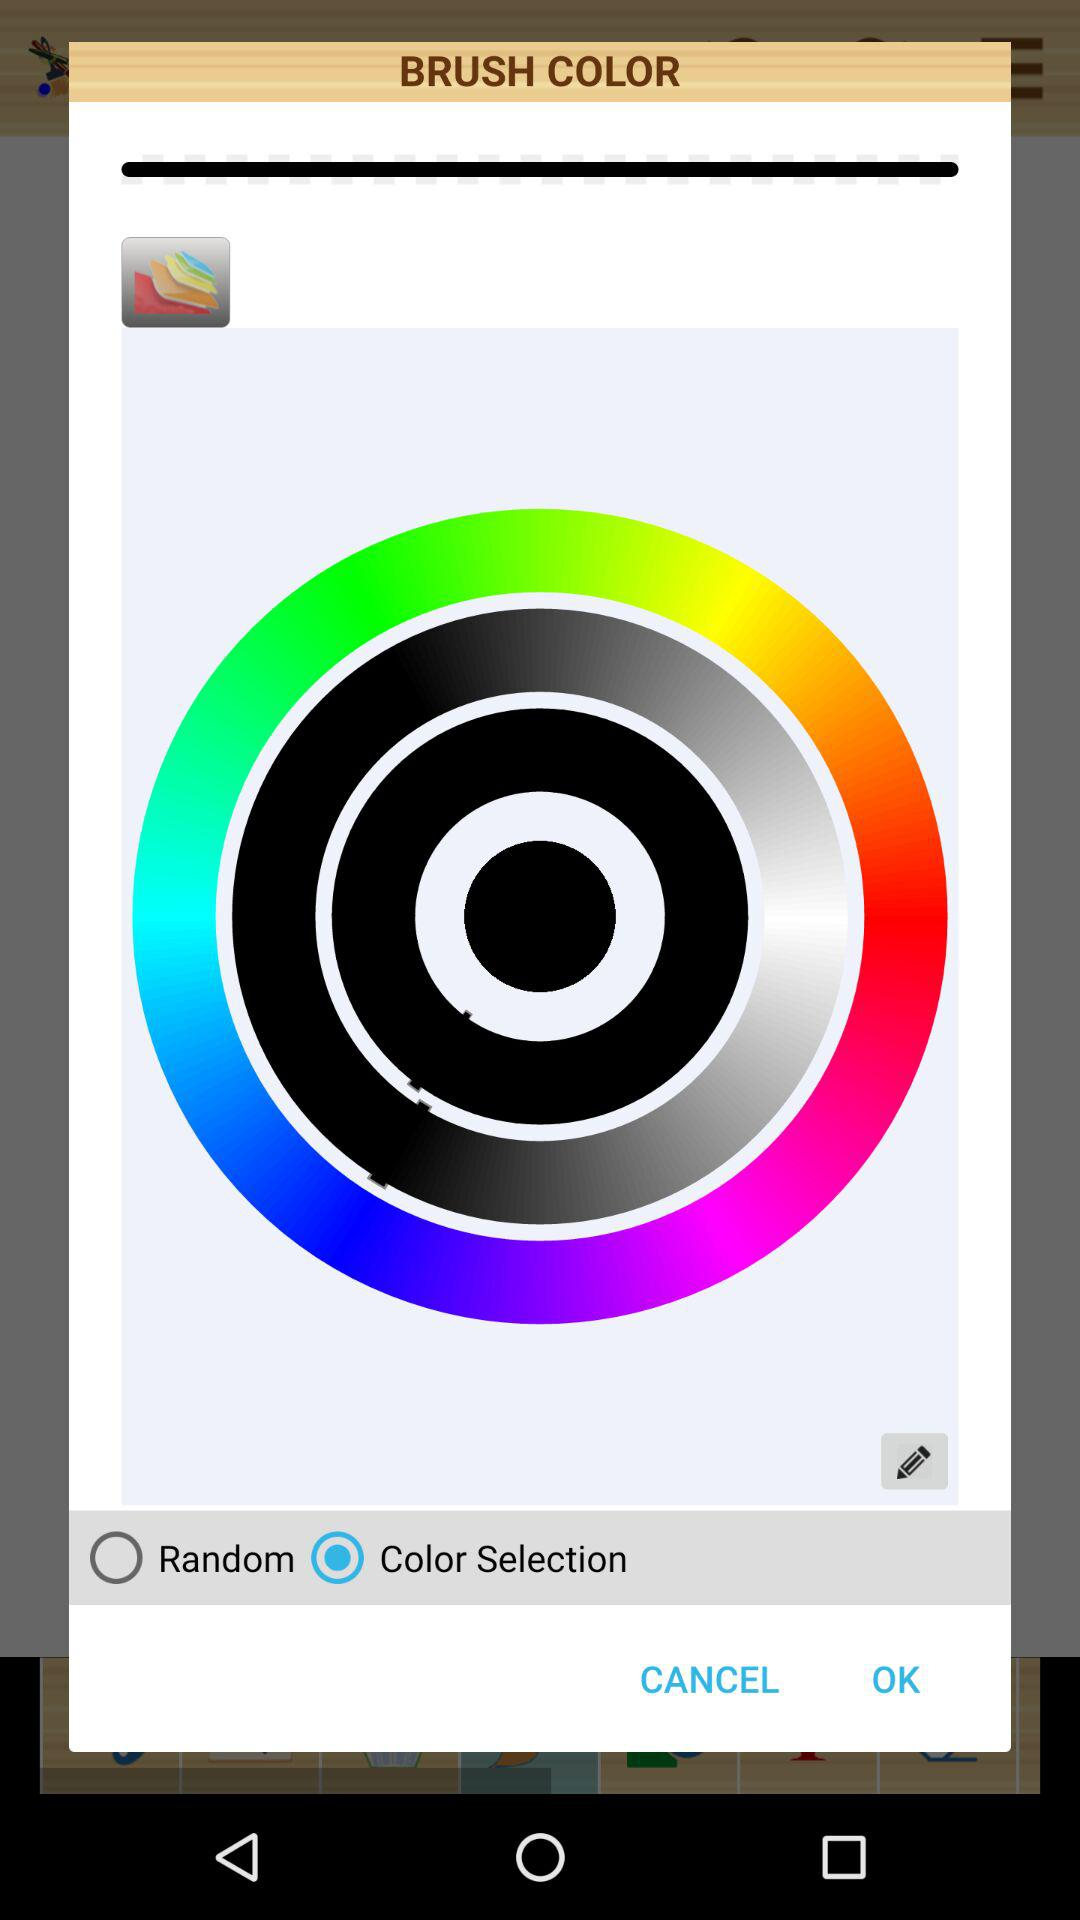What option is selected in brush color? The selected option is color selection. 